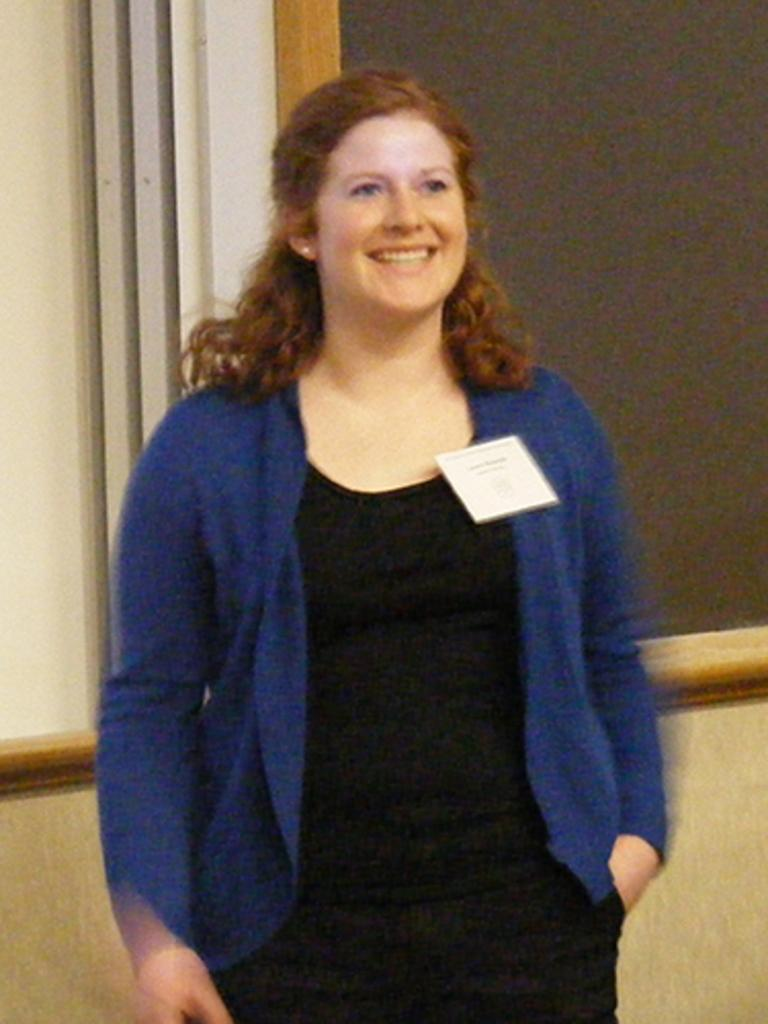What is present in the image? There is a person in the image. What can be observed about the person's attire? The person is wearing clothes. What architectural feature is visible in the image? There is a wall in the image. What type of pleasure can be seen on the owl's face in the image? There is no owl present in the image, so it is not possible to determine what type of pleasure might be seen on its face. 